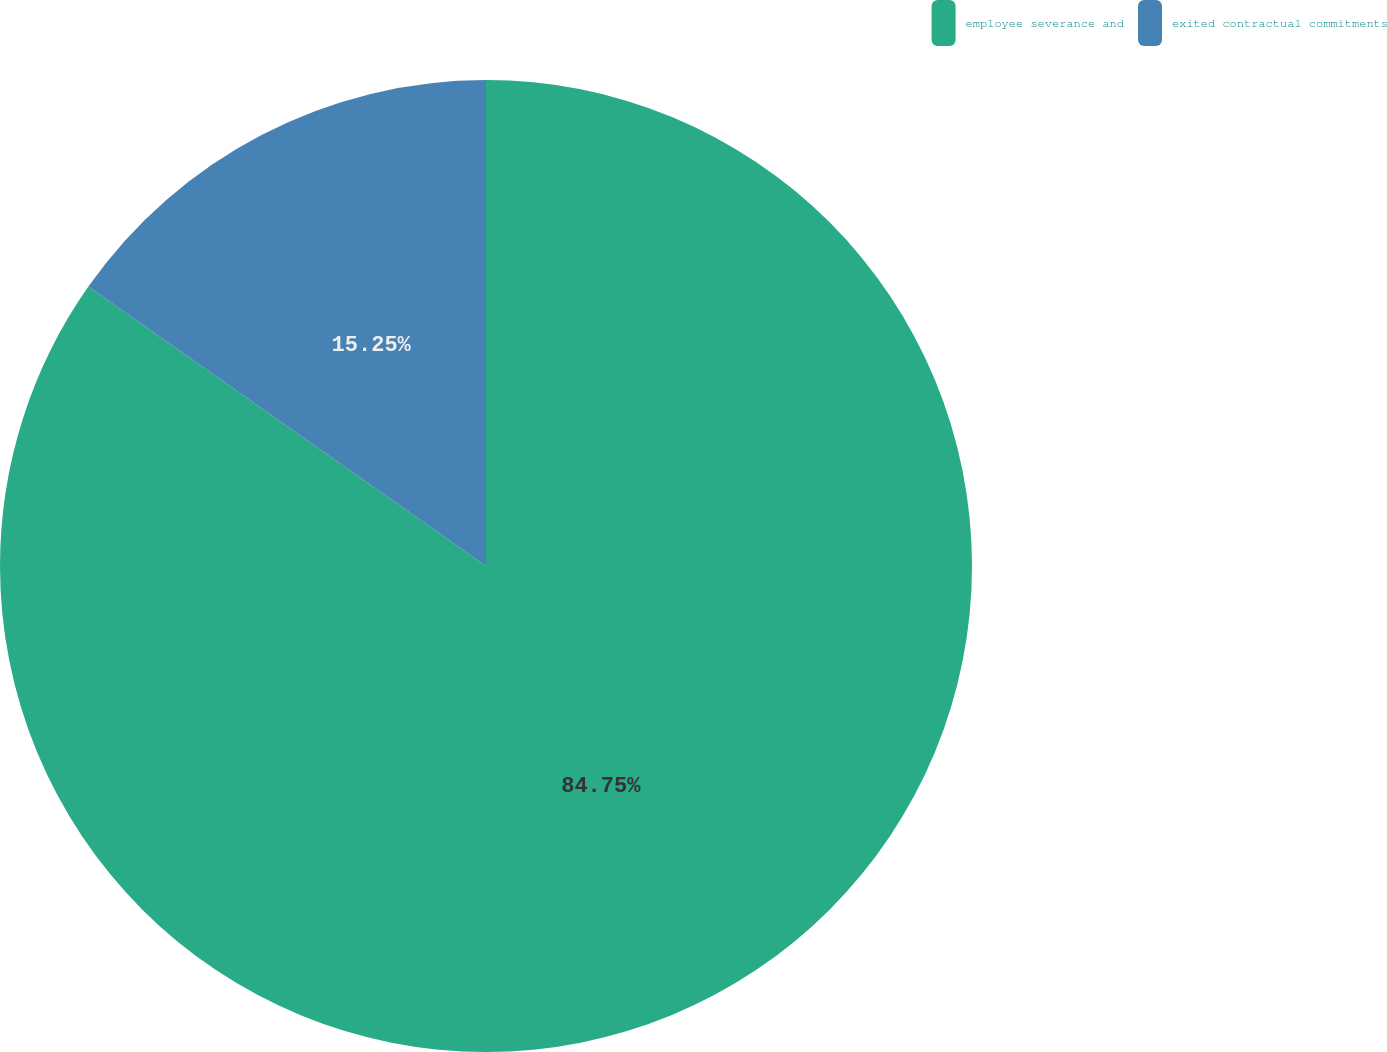Convert chart to OTSL. <chart><loc_0><loc_0><loc_500><loc_500><pie_chart><fcel>employee severance and<fcel>exited contractual commitments<nl><fcel>84.75%<fcel>15.25%<nl></chart> 